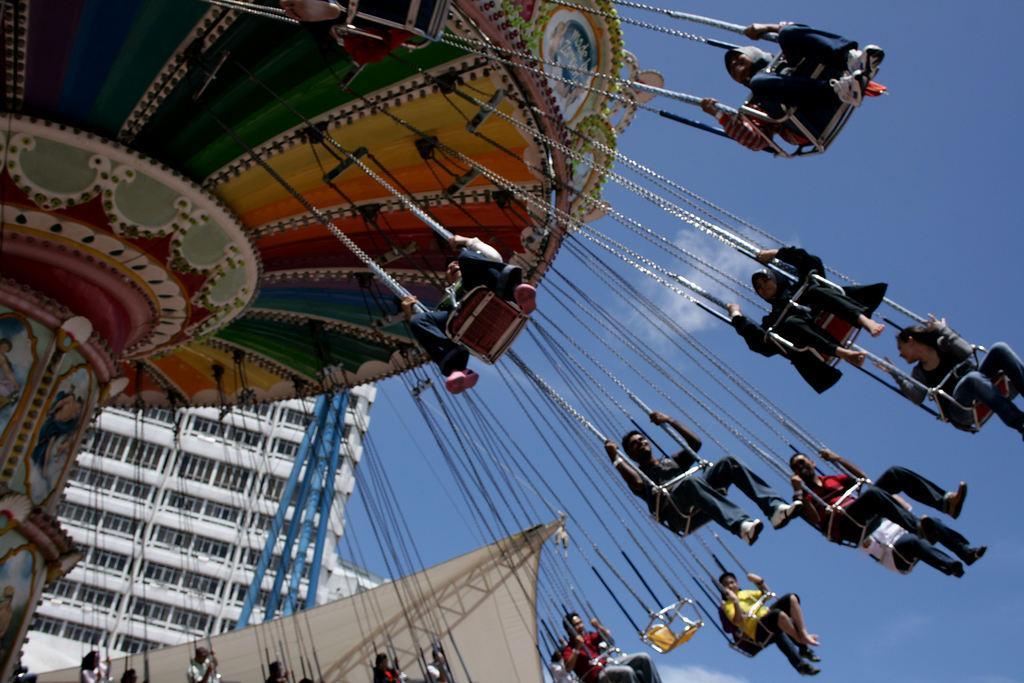Can you describe this image briefly? In this image I can see few people sitting on the giant wheel. These people are wearing the different color dresses and the giant wheel is colorful. To the side I can see the tent and the building. In the background I can see the clouds and the blue sky. 